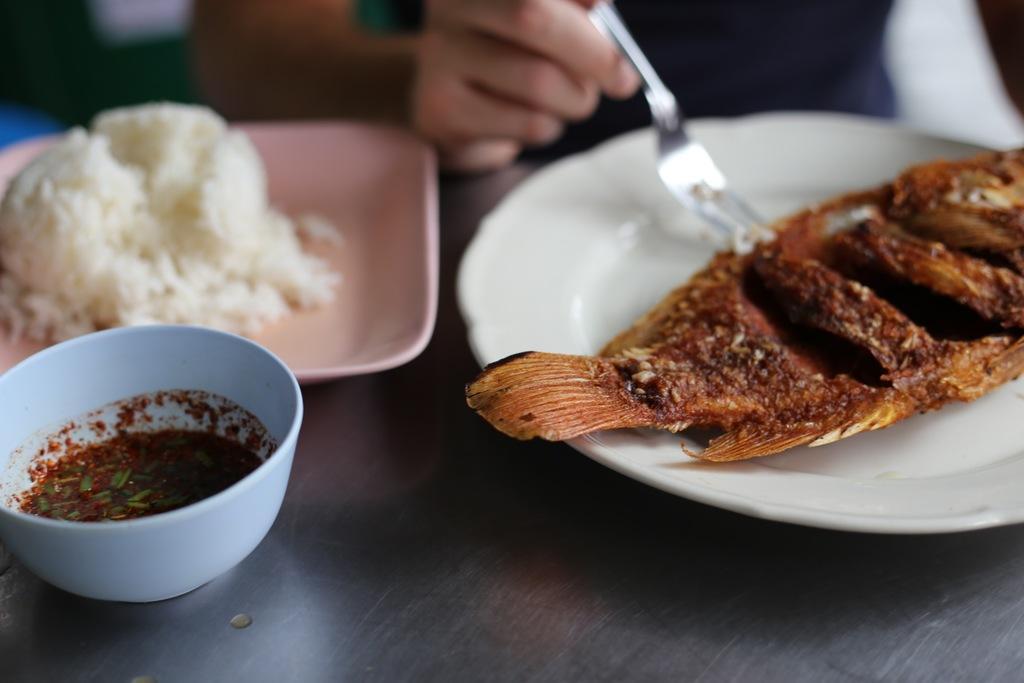Can you describe this image briefly? In this image we can see a fish on the plate. There is some food on the plate at the left side of the image. There is some soup in the bowl. A person is holding a spoon at the top of the image. We can see plates and bowl is placed on the table. 